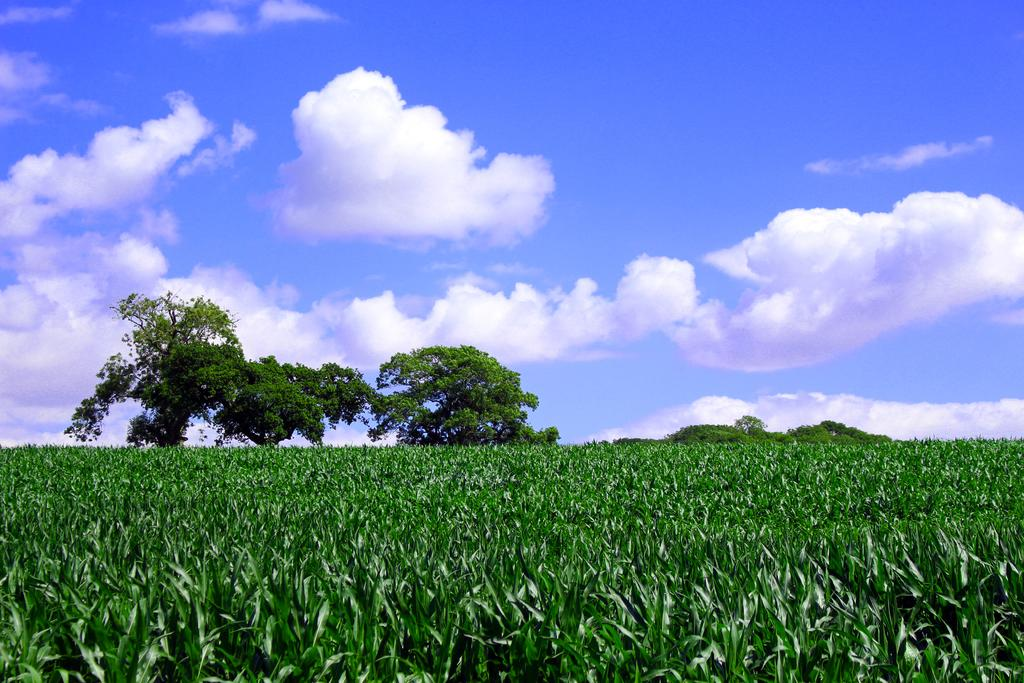What type of living organisms can be seen in the image? Plants can be seen in the image. What can be seen in the background of the image? There are trees and the sky visible in the background of the image. What type of zinc is present in the image? There is no zinc present in the image. What type of business is being conducted in the image? There is no indication of any business activity in the image. 